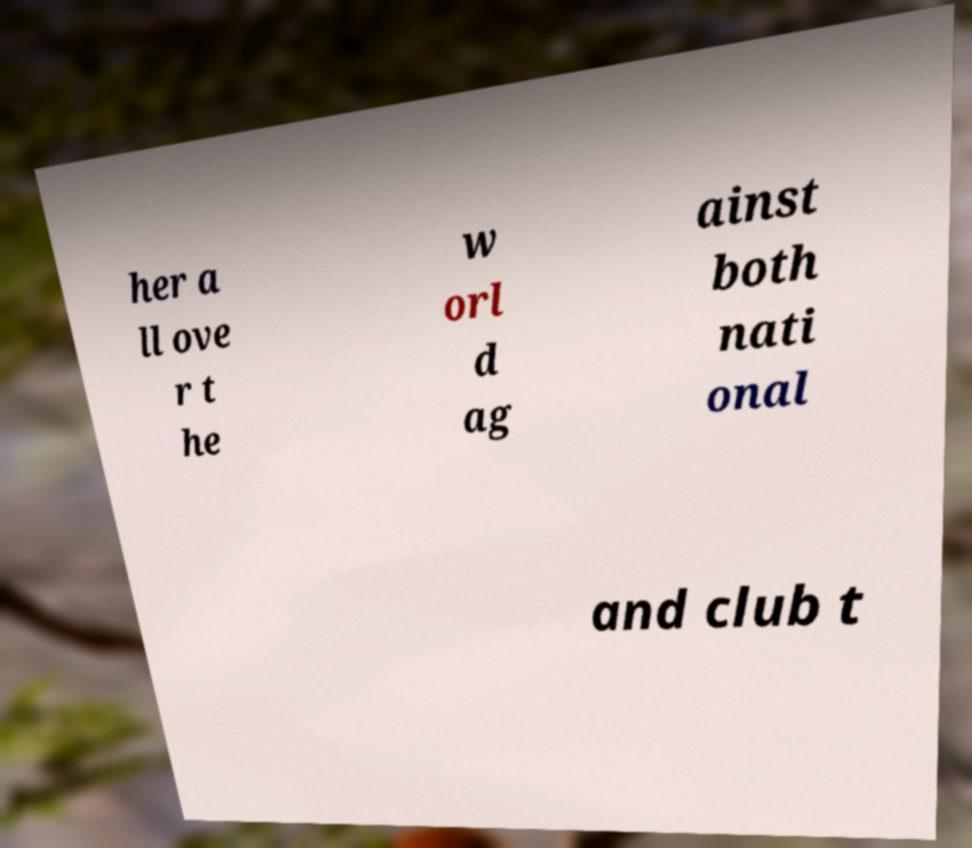There's text embedded in this image that I need extracted. Can you transcribe it verbatim? her a ll ove r t he w orl d ag ainst both nati onal and club t 